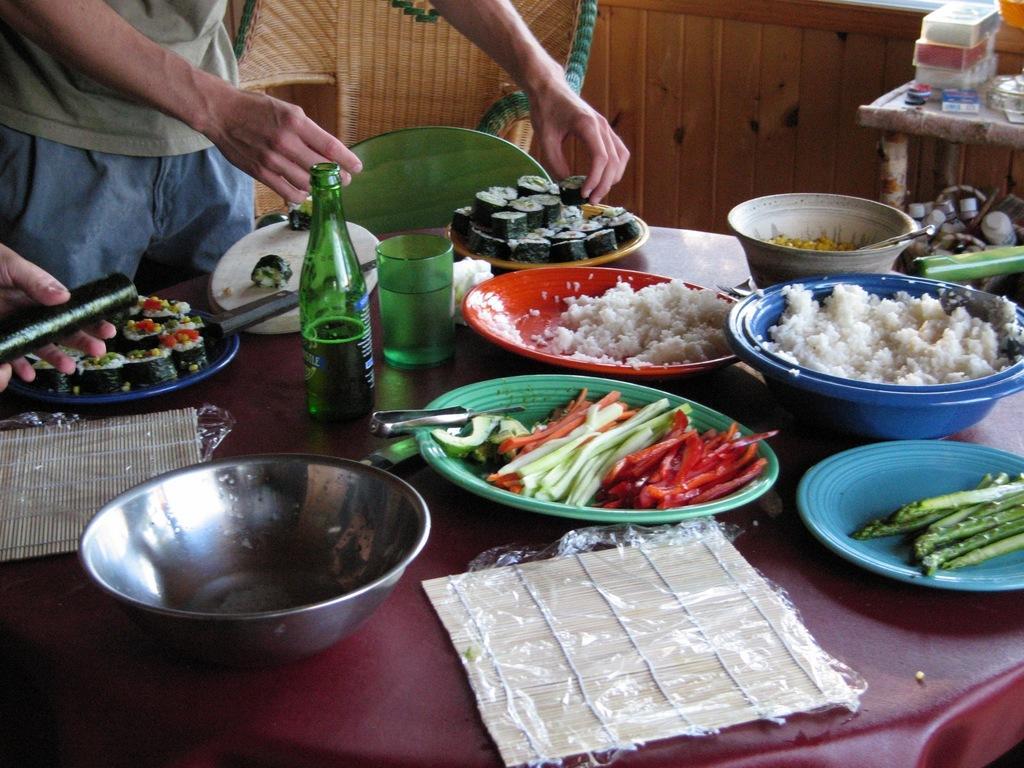Could you give a brief overview of what you see in this image? In this picture we can see a table and a chair, there are bowls, plates, a glass, a bottle present on the table, we can see a person standing here, on the right side there is another table, in this bowl we can see some rice, there are some vegetables in this bowl, we can see a knife here. 